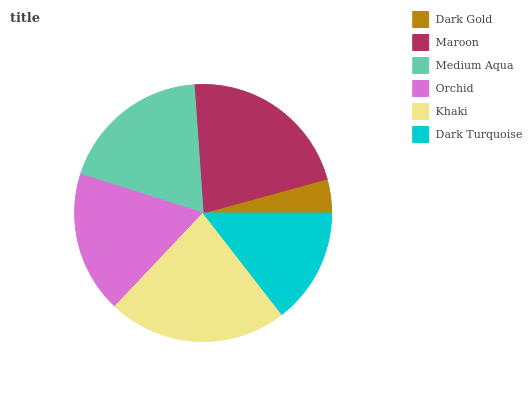Is Dark Gold the minimum?
Answer yes or no. Yes. Is Khaki the maximum?
Answer yes or no. Yes. Is Maroon the minimum?
Answer yes or no. No. Is Maroon the maximum?
Answer yes or no. No. Is Maroon greater than Dark Gold?
Answer yes or no. Yes. Is Dark Gold less than Maroon?
Answer yes or no. Yes. Is Dark Gold greater than Maroon?
Answer yes or no. No. Is Maroon less than Dark Gold?
Answer yes or no. No. Is Medium Aqua the high median?
Answer yes or no. Yes. Is Orchid the low median?
Answer yes or no. Yes. Is Maroon the high median?
Answer yes or no. No. Is Dark Turquoise the low median?
Answer yes or no. No. 